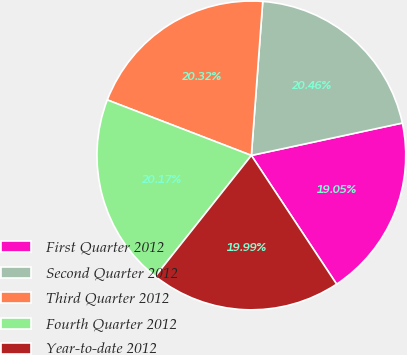Convert chart to OTSL. <chart><loc_0><loc_0><loc_500><loc_500><pie_chart><fcel>First Quarter 2012<fcel>Second Quarter 2012<fcel>Third Quarter 2012<fcel>Fourth Quarter 2012<fcel>Year-to-date 2012<nl><fcel>19.05%<fcel>20.46%<fcel>20.32%<fcel>20.17%<fcel>19.99%<nl></chart> 